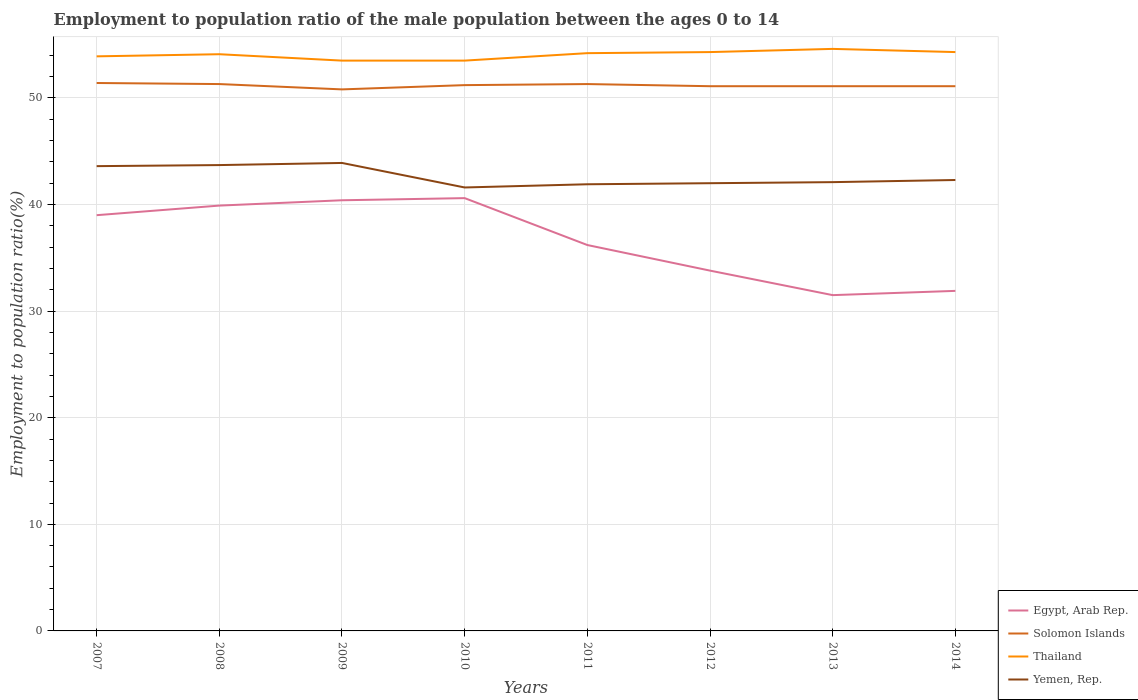Does the line corresponding to Solomon Islands intersect with the line corresponding to Yemen, Rep.?
Give a very brief answer. No. Is the number of lines equal to the number of legend labels?
Your response must be concise. Yes. Across all years, what is the maximum employment to population ratio in Thailand?
Make the answer very short. 53.5. What is the total employment to population ratio in Yemen, Rep. in the graph?
Offer a terse response. 2. What is the difference between the highest and the second highest employment to population ratio in Thailand?
Your answer should be very brief. 1.1. How many lines are there?
Offer a terse response. 4. What is the difference between two consecutive major ticks on the Y-axis?
Ensure brevity in your answer.  10. Are the values on the major ticks of Y-axis written in scientific E-notation?
Your answer should be compact. No. Does the graph contain grids?
Your answer should be compact. Yes. How many legend labels are there?
Provide a succinct answer. 4. What is the title of the graph?
Your response must be concise. Employment to population ratio of the male population between the ages 0 to 14. Does "Moldova" appear as one of the legend labels in the graph?
Offer a very short reply. No. What is the label or title of the X-axis?
Offer a very short reply. Years. What is the label or title of the Y-axis?
Your response must be concise. Employment to population ratio(%). What is the Employment to population ratio(%) in Egypt, Arab Rep. in 2007?
Offer a terse response. 39. What is the Employment to population ratio(%) in Solomon Islands in 2007?
Your response must be concise. 51.4. What is the Employment to population ratio(%) in Thailand in 2007?
Ensure brevity in your answer.  53.9. What is the Employment to population ratio(%) of Yemen, Rep. in 2007?
Keep it short and to the point. 43.6. What is the Employment to population ratio(%) of Egypt, Arab Rep. in 2008?
Offer a very short reply. 39.9. What is the Employment to population ratio(%) of Solomon Islands in 2008?
Ensure brevity in your answer.  51.3. What is the Employment to population ratio(%) in Thailand in 2008?
Keep it short and to the point. 54.1. What is the Employment to population ratio(%) of Yemen, Rep. in 2008?
Keep it short and to the point. 43.7. What is the Employment to population ratio(%) of Egypt, Arab Rep. in 2009?
Make the answer very short. 40.4. What is the Employment to population ratio(%) of Solomon Islands in 2009?
Make the answer very short. 50.8. What is the Employment to population ratio(%) in Thailand in 2009?
Your answer should be compact. 53.5. What is the Employment to population ratio(%) of Yemen, Rep. in 2009?
Offer a very short reply. 43.9. What is the Employment to population ratio(%) in Egypt, Arab Rep. in 2010?
Your answer should be compact. 40.6. What is the Employment to population ratio(%) in Solomon Islands in 2010?
Offer a terse response. 51.2. What is the Employment to population ratio(%) in Thailand in 2010?
Offer a very short reply. 53.5. What is the Employment to population ratio(%) in Yemen, Rep. in 2010?
Keep it short and to the point. 41.6. What is the Employment to population ratio(%) of Egypt, Arab Rep. in 2011?
Ensure brevity in your answer.  36.2. What is the Employment to population ratio(%) in Solomon Islands in 2011?
Offer a very short reply. 51.3. What is the Employment to population ratio(%) in Thailand in 2011?
Provide a short and direct response. 54.2. What is the Employment to population ratio(%) of Yemen, Rep. in 2011?
Offer a very short reply. 41.9. What is the Employment to population ratio(%) in Egypt, Arab Rep. in 2012?
Provide a succinct answer. 33.8. What is the Employment to population ratio(%) of Solomon Islands in 2012?
Keep it short and to the point. 51.1. What is the Employment to population ratio(%) in Thailand in 2012?
Give a very brief answer. 54.3. What is the Employment to population ratio(%) of Yemen, Rep. in 2012?
Your answer should be compact. 42. What is the Employment to population ratio(%) in Egypt, Arab Rep. in 2013?
Your answer should be very brief. 31.5. What is the Employment to population ratio(%) of Solomon Islands in 2013?
Your response must be concise. 51.1. What is the Employment to population ratio(%) of Thailand in 2013?
Offer a terse response. 54.6. What is the Employment to population ratio(%) in Yemen, Rep. in 2013?
Offer a very short reply. 42.1. What is the Employment to population ratio(%) in Egypt, Arab Rep. in 2014?
Provide a short and direct response. 31.9. What is the Employment to population ratio(%) of Solomon Islands in 2014?
Give a very brief answer. 51.1. What is the Employment to population ratio(%) of Thailand in 2014?
Your answer should be compact. 54.3. What is the Employment to population ratio(%) of Yemen, Rep. in 2014?
Provide a succinct answer. 42.3. Across all years, what is the maximum Employment to population ratio(%) of Egypt, Arab Rep.?
Ensure brevity in your answer.  40.6. Across all years, what is the maximum Employment to population ratio(%) in Solomon Islands?
Ensure brevity in your answer.  51.4. Across all years, what is the maximum Employment to population ratio(%) in Thailand?
Your response must be concise. 54.6. Across all years, what is the maximum Employment to population ratio(%) in Yemen, Rep.?
Ensure brevity in your answer.  43.9. Across all years, what is the minimum Employment to population ratio(%) in Egypt, Arab Rep.?
Offer a very short reply. 31.5. Across all years, what is the minimum Employment to population ratio(%) in Solomon Islands?
Offer a terse response. 50.8. Across all years, what is the minimum Employment to population ratio(%) of Thailand?
Keep it short and to the point. 53.5. Across all years, what is the minimum Employment to population ratio(%) of Yemen, Rep.?
Ensure brevity in your answer.  41.6. What is the total Employment to population ratio(%) of Egypt, Arab Rep. in the graph?
Offer a terse response. 293.3. What is the total Employment to population ratio(%) in Solomon Islands in the graph?
Keep it short and to the point. 409.3. What is the total Employment to population ratio(%) of Thailand in the graph?
Provide a short and direct response. 432.4. What is the total Employment to population ratio(%) of Yemen, Rep. in the graph?
Keep it short and to the point. 341.1. What is the difference between the Employment to population ratio(%) of Egypt, Arab Rep. in 2007 and that in 2008?
Your response must be concise. -0.9. What is the difference between the Employment to population ratio(%) of Yemen, Rep. in 2007 and that in 2008?
Provide a succinct answer. -0.1. What is the difference between the Employment to population ratio(%) of Egypt, Arab Rep. in 2007 and that in 2009?
Your response must be concise. -1.4. What is the difference between the Employment to population ratio(%) in Solomon Islands in 2007 and that in 2009?
Offer a terse response. 0.6. What is the difference between the Employment to population ratio(%) of Thailand in 2007 and that in 2009?
Your answer should be compact. 0.4. What is the difference between the Employment to population ratio(%) in Yemen, Rep. in 2007 and that in 2009?
Provide a short and direct response. -0.3. What is the difference between the Employment to population ratio(%) of Egypt, Arab Rep. in 2007 and that in 2010?
Your answer should be compact. -1.6. What is the difference between the Employment to population ratio(%) of Yemen, Rep. in 2007 and that in 2010?
Ensure brevity in your answer.  2. What is the difference between the Employment to population ratio(%) of Solomon Islands in 2007 and that in 2011?
Ensure brevity in your answer.  0.1. What is the difference between the Employment to population ratio(%) of Egypt, Arab Rep. in 2007 and that in 2012?
Your response must be concise. 5.2. What is the difference between the Employment to population ratio(%) in Solomon Islands in 2007 and that in 2012?
Ensure brevity in your answer.  0.3. What is the difference between the Employment to population ratio(%) of Thailand in 2007 and that in 2012?
Provide a short and direct response. -0.4. What is the difference between the Employment to population ratio(%) of Yemen, Rep. in 2007 and that in 2013?
Your response must be concise. 1.5. What is the difference between the Employment to population ratio(%) of Egypt, Arab Rep. in 2007 and that in 2014?
Provide a short and direct response. 7.1. What is the difference between the Employment to population ratio(%) of Solomon Islands in 2007 and that in 2014?
Offer a terse response. 0.3. What is the difference between the Employment to population ratio(%) in Thailand in 2007 and that in 2014?
Make the answer very short. -0.4. What is the difference between the Employment to population ratio(%) in Yemen, Rep. in 2007 and that in 2014?
Keep it short and to the point. 1.3. What is the difference between the Employment to population ratio(%) in Egypt, Arab Rep. in 2008 and that in 2009?
Your answer should be very brief. -0.5. What is the difference between the Employment to population ratio(%) in Solomon Islands in 2008 and that in 2009?
Your response must be concise. 0.5. What is the difference between the Employment to population ratio(%) in Thailand in 2008 and that in 2009?
Ensure brevity in your answer.  0.6. What is the difference between the Employment to population ratio(%) in Yemen, Rep. in 2008 and that in 2009?
Give a very brief answer. -0.2. What is the difference between the Employment to population ratio(%) of Egypt, Arab Rep. in 2008 and that in 2010?
Make the answer very short. -0.7. What is the difference between the Employment to population ratio(%) in Yemen, Rep. in 2008 and that in 2010?
Your answer should be compact. 2.1. What is the difference between the Employment to population ratio(%) in Solomon Islands in 2008 and that in 2011?
Offer a terse response. 0. What is the difference between the Employment to population ratio(%) of Yemen, Rep. in 2008 and that in 2011?
Your answer should be very brief. 1.8. What is the difference between the Employment to population ratio(%) of Egypt, Arab Rep. in 2008 and that in 2012?
Offer a terse response. 6.1. What is the difference between the Employment to population ratio(%) in Egypt, Arab Rep. in 2008 and that in 2013?
Your answer should be compact. 8.4. What is the difference between the Employment to population ratio(%) in Yemen, Rep. in 2008 and that in 2013?
Your answer should be compact. 1.6. What is the difference between the Employment to population ratio(%) of Solomon Islands in 2008 and that in 2014?
Make the answer very short. 0.2. What is the difference between the Employment to population ratio(%) of Solomon Islands in 2009 and that in 2010?
Offer a very short reply. -0.4. What is the difference between the Employment to population ratio(%) of Solomon Islands in 2009 and that in 2011?
Provide a short and direct response. -0.5. What is the difference between the Employment to population ratio(%) of Thailand in 2009 and that in 2011?
Your response must be concise. -0.7. What is the difference between the Employment to population ratio(%) in Yemen, Rep. in 2009 and that in 2011?
Your answer should be compact. 2. What is the difference between the Employment to population ratio(%) of Solomon Islands in 2009 and that in 2012?
Make the answer very short. -0.3. What is the difference between the Employment to population ratio(%) in Thailand in 2009 and that in 2012?
Your answer should be compact. -0.8. What is the difference between the Employment to population ratio(%) in Egypt, Arab Rep. in 2009 and that in 2013?
Your answer should be compact. 8.9. What is the difference between the Employment to population ratio(%) of Yemen, Rep. in 2009 and that in 2013?
Offer a very short reply. 1.8. What is the difference between the Employment to population ratio(%) in Egypt, Arab Rep. in 2009 and that in 2014?
Ensure brevity in your answer.  8.5. What is the difference between the Employment to population ratio(%) of Yemen, Rep. in 2009 and that in 2014?
Offer a terse response. 1.6. What is the difference between the Employment to population ratio(%) in Egypt, Arab Rep. in 2010 and that in 2011?
Ensure brevity in your answer.  4.4. What is the difference between the Employment to population ratio(%) in Solomon Islands in 2010 and that in 2011?
Give a very brief answer. -0.1. What is the difference between the Employment to population ratio(%) in Yemen, Rep. in 2010 and that in 2011?
Give a very brief answer. -0.3. What is the difference between the Employment to population ratio(%) in Thailand in 2010 and that in 2012?
Offer a terse response. -0.8. What is the difference between the Employment to population ratio(%) of Yemen, Rep. in 2010 and that in 2012?
Keep it short and to the point. -0.4. What is the difference between the Employment to population ratio(%) of Thailand in 2010 and that in 2013?
Your response must be concise. -1.1. What is the difference between the Employment to population ratio(%) in Solomon Islands in 2010 and that in 2014?
Give a very brief answer. 0.1. What is the difference between the Employment to population ratio(%) in Egypt, Arab Rep. in 2011 and that in 2012?
Ensure brevity in your answer.  2.4. What is the difference between the Employment to population ratio(%) in Yemen, Rep. in 2011 and that in 2012?
Make the answer very short. -0.1. What is the difference between the Employment to population ratio(%) of Yemen, Rep. in 2011 and that in 2013?
Your response must be concise. -0.2. What is the difference between the Employment to population ratio(%) in Solomon Islands in 2011 and that in 2014?
Provide a short and direct response. 0.2. What is the difference between the Employment to population ratio(%) in Yemen, Rep. in 2011 and that in 2014?
Offer a very short reply. -0.4. What is the difference between the Employment to population ratio(%) of Thailand in 2012 and that in 2013?
Your answer should be compact. -0.3. What is the difference between the Employment to population ratio(%) in Yemen, Rep. in 2012 and that in 2013?
Provide a succinct answer. -0.1. What is the difference between the Employment to population ratio(%) of Solomon Islands in 2012 and that in 2014?
Ensure brevity in your answer.  0. What is the difference between the Employment to population ratio(%) in Thailand in 2012 and that in 2014?
Provide a succinct answer. 0. What is the difference between the Employment to population ratio(%) of Yemen, Rep. in 2012 and that in 2014?
Provide a short and direct response. -0.3. What is the difference between the Employment to population ratio(%) of Solomon Islands in 2013 and that in 2014?
Make the answer very short. 0. What is the difference between the Employment to population ratio(%) of Thailand in 2013 and that in 2014?
Ensure brevity in your answer.  0.3. What is the difference between the Employment to population ratio(%) of Egypt, Arab Rep. in 2007 and the Employment to population ratio(%) of Thailand in 2008?
Your answer should be compact. -15.1. What is the difference between the Employment to population ratio(%) in Solomon Islands in 2007 and the Employment to population ratio(%) in Thailand in 2008?
Offer a terse response. -2.7. What is the difference between the Employment to population ratio(%) in Solomon Islands in 2007 and the Employment to population ratio(%) in Yemen, Rep. in 2008?
Offer a very short reply. 7.7. What is the difference between the Employment to population ratio(%) of Thailand in 2007 and the Employment to population ratio(%) of Yemen, Rep. in 2008?
Offer a terse response. 10.2. What is the difference between the Employment to population ratio(%) of Egypt, Arab Rep. in 2007 and the Employment to population ratio(%) of Yemen, Rep. in 2009?
Provide a short and direct response. -4.9. What is the difference between the Employment to population ratio(%) of Solomon Islands in 2007 and the Employment to population ratio(%) of Yemen, Rep. in 2009?
Ensure brevity in your answer.  7.5. What is the difference between the Employment to population ratio(%) in Thailand in 2007 and the Employment to population ratio(%) in Yemen, Rep. in 2009?
Your answer should be compact. 10. What is the difference between the Employment to population ratio(%) in Egypt, Arab Rep. in 2007 and the Employment to population ratio(%) in Thailand in 2010?
Give a very brief answer. -14.5. What is the difference between the Employment to population ratio(%) in Thailand in 2007 and the Employment to population ratio(%) in Yemen, Rep. in 2010?
Ensure brevity in your answer.  12.3. What is the difference between the Employment to population ratio(%) of Egypt, Arab Rep. in 2007 and the Employment to population ratio(%) of Solomon Islands in 2011?
Ensure brevity in your answer.  -12.3. What is the difference between the Employment to population ratio(%) of Egypt, Arab Rep. in 2007 and the Employment to population ratio(%) of Thailand in 2011?
Provide a succinct answer. -15.2. What is the difference between the Employment to population ratio(%) of Egypt, Arab Rep. in 2007 and the Employment to population ratio(%) of Yemen, Rep. in 2011?
Your response must be concise. -2.9. What is the difference between the Employment to population ratio(%) in Solomon Islands in 2007 and the Employment to population ratio(%) in Yemen, Rep. in 2011?
Your answer should be very brief. 9.5. What is the difference between the Employment to population ratio(%) of Egypt, Arab Rep. in 2007 and the Employment to population ratio(%) of Solomon Islands in 2012?
Your answer should be very brief. -12.1. What is the difference between the Employment to population ratio(%) in Egypt, Arab Rep. in 2007 and the Employment to population ratio(%) in Thailand in 2012?
Offer a terse response. -15.3. What is the difference between the Employment to population ratio(%) of Egypt, Arab Rep. in 2007 and the Employment to population ratio(%) of Yemen, Rep. in 2012?
Offer a very short reply. -3. What is the difference between the Employment to population ratio(%) in Solomon Islands in 2007 and the Employment to population ratio(%) in Thailand in 2012?
Your response must be concise. -2.9. What is the difference between the Employment to population ratio(%) in Egypt, Arab Rep. in 2007 and the Employment to population ratio(%) in Solomon Islands in 2013?
Your answer should be compact. -12.1. What is the difference between the Employment to population ratio(%) in Egypt, Arab Rep. in 2007 and the Employment to population ratio(%) in Thailand in 2013?
Ensure brevity in your answer.  -15.6. What is the difference between the Employment to population ratio(%) of Egypt, Arab Rep. in 2007 and the Employment to population ratio(%) of Yemen, Rep. in 2013?
Your answer should be very brief. -3.1. What is the difference between the Employment to population ratio(%) in Solomon Islands in 2007 and the Employment to population ratio(%) in Thailand in 2013?
Offer a terse response. -3.2. What is the difference between the Employment to population ratio(%) of Solomon Islands in 2007 and the Employment to population ratio(%) of Yemen, Rep. in 2013?
Offer a very short reply. 9.3. What is the difference between the Employment to population ratio(%) of Egypt, Arab Rep. in 2007 and the Employment to population ratio(%) of Solomon Islands in 2014?
Make the answer very short. -12.1. What is the difference between the Employment to population ratio(%) of Egypt, Arab Rep. in 2007 and the Employment to population ratio(%) of Thailand in 2014?
Keep it short and to the point. -15.3. What is the difference between the Employment to population ratio(%) of Thailand in 2007 and the Employment to population ratio(%) of Yemen, Rep. in 2014?
Provide a succinct answer. 11.6. What is the difference between the Employment to population ratio(%) of Egypt, Arab Rep. in 2008 and the Employment to population ratio(%) of Solomon Islands in 2009?
Offer a very short reply. -10.9. What is the difference between the Employment to population ratio(%) in Egypt, Arab Rep. in 2008 and the Employment to population ratio(%) in Thailand in 2009?
Offer a terse response. -13.6. What is the difference between the Employment to population ratio(%) of Solomon Islands in 2008 and the Employment to population ratio(%) of Thailand in 2009?
Your response must be concise. -2.2. What is the difference between the Employment to population ratio(%) in Thailand in 2008 and the Employment to population ratio(%) in Yemen, Rep. in 2009?
Keep it short and to the point. 10.2. What is the difference between the Employment to population ratio(%) of Egypt, Arab Rep. in 2008 and the Employment to population ratio(%) of Solomon Islands in 2010?
Provide a short and direct response. -11.3. What is the difference between the Employment to population ratio(%) in Egypt, Arab Rep. in 2008 and the Employment to population ratio(%) in Yemen, Rep. in 2010?
Provide a short and direct response. -1.7. What is the difference between the Employment to population ratio(%) of Solomon Islands in 2008 and the Employment to population ratio(%) of Thailand in 2010?
Keep it short and to the point. -2.2. What is the difference between the Employment to population ratio(%) of Solomon Islands in 2008 and the Employment to population ratio(%) of Yemen, Rep. in 2010?
Make the answer very short. 9.7. What is the difference between the Employment to population ratio(%) in Egypt, Arab Rep. in 2008 and the Employment to population ratio(%) in Thailand in 2011?
Give a very brief answer. -14.3. What is the difference between the Employment to population ratio(%) of Solomon Islands in 2008 and the Employment to population ratio(%) of Thailand in 2011?
Make the answer very short. -2.9. What is the difference between the Employment to population ratio(%) in Solomon Islands in 2008 and the Employment to population ratio(%) in Yemen, Rep. in 2011?
Ensure brevity in your answer.  9.4. What is the difference between the Employment to population ratio(%) in Thailand in 2008 and the Employment to population ratio(%) in Yemen, Rep. in 2011?
Give a very brief answer. 12.2. What is the difference between the Employment to population ratio(%) of Egypt, Arab Rep. in 2008 and the Employment to population ratio(%) of Solomon Islands in 2012?
Your response must be concise. -11.2. What is the difference between the Employment to population ratio(%) of Egypt, Arab Rep. in 2008 and the Employment to population ratio(%) of Thailand in 2012?
Offer a terse response. -14.4. What is the difference between the Employment to population ratio(%) in Solomon Islands in 2008 and the Employment to population ratio(%) in Thailand in 2012?
Give a very brief answer. -3. What is the difference between the Employment to population ratio(%) of Solomon Islands in 2008 and the Employment to population ratio(%) of Yemen, Rep. in 2012?
Give a very brief answer. 9.3. What is the difference between the Employment to population ratio(%) of Thailand in 2008 and the Employment to population ratio(%) of Yemen, Rep. in 2012?
Your answer should be very brief. 12.1. What is the difference between the Employment to population ratio(%) of Egypt, Arab Rep. in 2008 and the Employment to population ratio(%) of Thailand in 2013?
Give a very brief answer. -14.7. What is the difference between the Employment to population ratio(%) in Solomon Islands in 2008 and the Employment to population ratio(%) in Thailand in 2013?
Your answer should be very brief. -3.3. What is the difference between the Employment to population ratio(%) in Solomon Islands in 2008 and the Employment to population ratio(%) in Yemen, Rep. in 2013?
Give a very brief answer. 9.2. What is the difference between the Employment to population ratio(%) of Thailand in 2008 and the Employment to population ratio(%) of Yemen, Rep. in 2013?
Keep it short and to the point. 12. What is the difference between the Employment to population ratio(%) in Egypt, Arab Rep. in 2008 and the Employment to population ratio(%) in Thailand in 2014?
Offer a very short reply. -14.4. What is the difference between the Employment to population ratio(%) of Egypt, Arab Rep. in 2008 and the Employment to population ratio(%) of Yemen, Rep. in 2014?
Offer a very short reply. -2.4. What is the difference between the Employment to population ratio(%) in Solomon Islands in 2008 and the Employment to population ratio(%) in Thailand in 2014?
Offer a terse response. -3. What is the difference between the Employment to population ratio(%) in Egypt, Arab Rep. in 2009 and the Employment to population ratio(%) in Solomon Islands in 2010?
Your answer should be compact. -10.8. What is the difference between the Employment to population ratio(%) in Egypt, Arab Rep. in 2009 and the Employment to population ratio(%) in Thailand in 2010?
Provide a succinct answer. -13.1. What is the difference between the Employment to population ratio(%) of Egypt, Arab Rep. in 2009 and the Employment to population ratio(%) of Yemen, Rep. in 2010?
Your answer should be compact. -1.2. What is the difference between the Employment to population ratio(%) of Solomon Islands in 2009 and the Employment to population ratio(%) of Yemen, Rep. in 2010?
Make the answer very short. 9.2. What is the difference between the Employment to population ratio(%) of Egypt, Arab Rep. in 2009 and the Employment to population ratio(%) of Solomon Islands in 2011?
Provide a succinct answer. -10.9. What is the difference between the Employment to population ratio(%) in Egypt, Arab Rep. in 2009 and the Employment to population ratio(%) in Thailand in 2011?
Your answer should be compact. -13.8. What is the difference between the Employment to population ratio(%) of Egypt, Arab Rep. in 2009 and the Employment to population ratio(%) of Yemen, Rep. in 2011?
Your answer should be very brief. -1.5. What is the difference between the Employment to population ratio(%) in Solomon Islands in 2009 and the Employment to population ratio(%) in Yemen, Rep. in 2011?
Offer a very short reply. 8.9. What is the difference between the Employment to population ratio(%) of Thailand in 2009 and the Employment to population ratio(%) of Yemen, Rep. in 2011?
Keep it short and to the point. 11.6. What is the difference between the Employment to population ratio(%) of Egypt, Arab Rep. in 2009 and the Employment to population ratio(%) of Solomon Islands in 2012?
Make the answer very short. -10.7. What is the difference between the Employment to population ratio(%) of Egypt, Arab Rep. in 2009 and the Employment to population ratio(%) of Thailand in 2012?
Provide a short and direct response. -13.9. What is the difference between the Employment to population ratio(%) in Egypt, Arab Rep. in 2009 and the Employment to population ratio(%) in Yemen, Rep. in 2012?
Provide a succinct answer. -1.6. What is the difference between the Employment to population ratio(%) of Solomon Islands in 2009 and the Employment to population ratio(%) of Thailand in 2012?
Your answer should be very brief. -3.5. What is the difference between the Employment to population ratio(%) in Egypt, Arab Rep. in 2009 and the Employment to population ratio(%) in Solomon Islands in 2013?
Provide a short and direct response. -10.7. What is the difference between the Employment to population ratio(%) in Egypt, Arab Rep. in 2009 and the Employment to population ratio(%) in Thailand in 2013?
Give a very brief answer. -14.2. What is the difference between the Employment to population ratio(%) of Egypt, Arab Rep. in 2009 and the Employment to population ratio(%) of Yemen, Rep. in 2013?
Offer a very short reply. -1.7. What is the difference between the Employment to population ratio(%) of Solomon Islands in 2009 and the Employment to population ratio(%) of Thailand in 2013?
Offer a terse response. -3.8. What is the difference between the Employment to population ratio(%) of Solomon Islands in 2009 and the Employment to population ratio(%) of Yemen, Rep. in 2013?
Provide a succinct answer. 8.7. What is the difference between the Employment to population ratio(%) in Egypt, Arab Rep. in 2009 and the Employment to population ratio(%) in Solomon Islands in 2014?
Offer a terse response. -10.7. What is the difference between the Employment to population ratio(%) in Egypt, Arab Rep. in 2009 and the Employment to population ratio(%) in Thailand in 2014?
Your answer should be very brief. -13.9. What is the difference between the Employment to population ratio(%) in Solomon Islands in 2009 and the Employment to population ratio(%) in Thailand in 2014?
Provide a succinct answer. -3.5. What is the difference between the Employment to population ratio(%) in Solomon Islands in 2009 and the Employment to population ratio(%) in Yemen, Rep. in 2014?
Make the answer very short. 8.5. What is the difference between the Employment to population ratio(%) of Egypt, Arab Rep. in 2010 and the Employment to population ratio(%) of Thailand in 2011?
Offer a terse response. -13.6. What is the difference between the Employment to population ratio(%) of Egypt, Arab Rep. in 2010 and the Employment to population ratio(%) of Yemen, Rep. in 2011?
Provide a succinct answer. -1.3. What is the difference between the Employment to population ratio(%) in Thailand in 2010 and the Employment to population ratio(%) in Yemen, Rep. in 2011?
Your answer should be compact. 11.6. What is the difference between the Employment to population ratio(%) in Egypt, Arab Rep. in 2010 and the Employment to population ratio(%) in Thailand in 2012?
Your answer should be very brief. -13.7. What is the difference between the Employment to population ratio(%) in Egypt, Arab Rep. in 2010 and the Employment to population ratio(%) in Yemen, Rep. in 2012?
Keep it short and to the point. -1.4. What is the difference between the Employment to population ratio(%) in Solomon Islands in 2010 and the Employment to population ratio(%) in Thailand in 2013?
Offer a very short reply. -3.4. What is the difference between the Employment to population ratio(%) in Solomon Islands in 2010 and the Employment to population ratio(%) in Yemen, Rep. in 2013?
Keep it short and to the point. 9.1. What is the difference between the Employment to population ratio(%) of Thailand in 2010 and the Employment to population ratio(%) of Yemen, Rep. in 2013?
Your response must be concise. 11.4. What is the difference between the Employment to population ratio(%) in Egypt, Arab Rep. in 2010 and the Employment to population ratio(%) in Solomon Islands in 2014?
Provide a succinct answer. -10.5. What is the difference between the Employment to population ratio(%) in Egypt, Arab Rep. in 2010 and the Employment to population ratio(%) in Thailand in 2014?
Ensure brevity in your answer.  -13.7. What is the difference between the Employment to population ratio(%) of Thailand in 2010 and the Employment to population ratio(%) of Yemen, Rep. in 2014?
Offer a very short reply. 11.2. What is the difference between the Employment to population ratio(%) in Egypt, Arab Rep. in 2011 and the Employment to population ratio(%) in Solomon Islands in 2012?
Give a very brief answer. -14.9. What is the difference between the Employment to population ratio(%) in Egypt, Arab Rep. in 2011 and the Employment to population ratio(%) in Thailand in 2012?
Offer a terse response. -18.1. What is the difference between the Employment to population ratio(%) in Solomon Islands in 2011 and the Employment to population ratio(%) in Thailand in 2012?
Offer a very short reply. -3. What is the difference between the Employment to population ratio(%) in Solomon Islands in 2011 and the Employment to population ratio(%) in Yemen, Rep. in 2012?
Keep it short and to the point. 9.3. What is the difference between the Employment to population ratio(%) in Thailand in 2011 and the Employment to population ratio(%) in Yemen, Rep. in 2012?
Keep it short and to the point. 12.2. What is the difference between the Employment to population ratio(%) of Egypt, Arab Rep. in 2011 and the Employment to population ratio(%) of Solomon Islands in 2013?
Offer a very short reply. -14.9. What is the difference between the Employment to population ratio(%) in Egypt, Arab Rep. in 2011 and the Employment to population ratio(%) in Thailand in 2013?
Your response must be concise. -18.4. What is the difference between the Employment to population ratio(%) in Solomon Islands in 2011 and the Employment to population ratio(%) in Thailand in 2013?
Ensure brevity in your answer.  -3.3. What is the difference between the Employment to population ratio(%) of Solomon Islands in 2011 and the Employment to population ratio(%) of Yemen, Rep. in 2013?
Your answer should be very brief. 9.2. What is the difference between the Employment to population ratio(%) in Egypt, Arab Rep. in 2011 and the Employment to population ratio(%) in Solomon Islands in 2014?
Ensure brevity in your answer.  -14.9. What is the difference between the Employment to population ratio(%) of Egypt, Arab Rep. in 2011 and the Employment to population ratio(%) of Thailand in 2014?
Keep it short and to the point. -18.1. What is the difference between the Employment to population ratio(%) of Solomon Islands in 2011 and the Employment to population ratio(%) of Yemen, Rep. in 2014?
Give a very brief answer. 9. What is the difference between the Employment to population ratio(%) of Egypt, Arab Rep. in 2012 and the Employment to population ratio(%) of Solomon Islands in 2013?
Give a very brief answer. -17.3. What is the difference between the Employment to population ratio(%) in Egypt, Arab Rep. in 2012 and the Employment to population ratio(%) in Thailand in 2013?
Give a very brief answer. -20.8. What is the difference between the Employment to population ratio(%) of Solomon Islands in 2012 and the Employment to population ratio(%) of Thailand in 2013?
Your response must be concise. -3.5. What is the difference between the Employment to population ratio(%) in Thailand in 2012 and the Employment to population ratio(%) in Yemen, Rep. in 2013?
Your answer should be very brief. 12.2. What is the difference between the Employment to population ratio(%) in Egypt, Arab Rep. in 2012 and the Employment to population ratio(%) in Solomon Islands in 2014?
Offer a terse response. -17.3. What is the difference between the Employment to population ratio(%) in Egypt, Arab Rep. in 2012 and the Employment to population ratio(%) in Thailand in 2014?
Your answer should be very brief. -20.5. What is the difference between the Employment to population ratio(%) in Egypt, Arab Rep. in 2012 and the Employment to population ratio(%) in Yemen, Rep. in 2014?
Offer a terse response. -8.5. What is the difference between the Employment to population ratio(%) of Solomon Islands in 2012 and the Employment to population ratio(%) of Thailand in 2014?
Provide a succinct answer. -3.2. What is the difference between the Employment to population ratio(%) of Solomon Islands in 2012 and the Employment to population ratio(%) of Yemen, Rep. in 2014?
Provide a succinct answer. 8.8. What is the difference between the Employment to population ratio(%) of Thailand in 2012 and the Employment to population ratio(%) of Yemen, Rep. in 2014?
Your answer should be very brief. 12. What is the difference between the Employment to population ratio(%) in Egypt, Arab Rep. in 2013 and the Employment to population ratio(%) in Solomon Islands in 2014?
Offer a very short reply. -19.6. What is the difference between the Employment to population ratio(%) of Egypt, Arab Rep. in 2013 and the Employment to population ratio(%) of Thailand in 2014?
Your answer should be compact. -22.8. What is the difference between the Employment to population ratio(%) of Egypt, Arab Rep. in 2013 and the Employment to population ratio(%) of Yemen, Rep. in 2014?
Offer a terse response. -10.8. What is the difference between the Employment to population ratio(%) of Thailand in 2013 and the Employment to population ratio(%) of Yemen, Rep. in 2014?
Provide a succinct answer. 12.3. What is the average Employment to population ratio(%) of Egypt, Arab Rep. per year?
Make the answer very short. 36.66. What is the average Employment to population ratio(%) of Solomon Islands per year?
Make the answer very short. 51.16. What is the average Employment to population ratio(%) of Thailand per year?
Offer a very short reply. 54.05. What is the average Employment to population ratio(%) of Yemen, Rep. per year?
Your answer should be compact. 42.64. In the year 2007, what is the difference between the Employment to population ratio(%) in Egypt, Arab Rep. and Employment to population ratio(%) in Thailand?
Provide a short and direct response. -14.9. In the year 2007, what is the difference between the Employment to population ratio(%) in Solomon Islands and Employment to population ratio(%) in Thailand?
Your answer should be compact. -2.5. In the year 2008, what is the difference between the Employment to population ratio(%) in Egypt, Arab Rep. and Employment to population ratio(%) in Yemen, Rep.?
Your answer should be very brief. -3.8. In the year 2009, what is the difference between the Employment to population ratio(%) in Egypt, Arab Rep. and Employment to population ratio(%) in Solomon Islands?
Give a very brief answer. -10.4. In the year 2009, what is the difference between the Employment to population ratio(%) in Egypt, Arab Rep. and Employment to population ratio(%) in Thailand?
Offer a terse response. -13.1. In the year 2009, what is the difference between the Employment to population ratio(%) of Egypt, Arab Rep. and Employment to population ratio(%) of Yemen, Rep.?
Give a very brief answer. -3.5. In the year 2009, what is the difference between the Employment to population ratio(%) of Solomon Islands and Employment to population ratio(%) of Thailand?
Your answer should be very brief. -2.7. In the year 2009, what is the difference between the Employment to population ratio(%) of Thailand and Employment to population ratio(%) of Yemen, Rep.?
Keep it short and to the point. 9.6. In the year 2010, what is the difference between the Employment to population ratio(%) in Thailand and Employment to population ratio(%) in Yemen, Rep.?
Your response must be concise. 11.9. In the year 2011, what is the difference between the Employment to population ratio(%) of Egypt, Arab Rep. and Employment to population ratio(%) of Solomon Islands?
Provide a succinct answer. -15.1. In the year 2011, what is the difference between the Employment to population ratio(%) of Egypt, Arab Rep. and Employment to population ratio(%) of Thailand?
Ensure brevity in your answer.  -18. In the year 2011, what is the difference between the Employment to population ratio(%) of Solomon Islands and Employment to population ratio(%) of Yemen, Rep.?
Provide a short and direct response. 9.4. In the year 2012, what is the difference between the Employment to population ratio(%) of Egypt, Arab Rep. and Employment to population ratio(%) of Solomon Islands?
Give a very brief answer. -17.3. In the year 2012, what is the difference between the Employment to population ratio(%) of Egypt, Arab Rep. and Employment to population ratio(%) of Thailand?
Your answer should be very brief. -20.5. In the year 2012, what is the difference between the Employment to population ratio(%) of Solomon Islands and Employment to population ratio(%) of Thailand?
Ensure brevity in your answer.  -3.2. In the year 2012, what is the difference between the Employment to population ratio(%) in Solomon Islands and Employment to population ratio(%) in Yemen, Rep.?
Offer a terse response. 9.1. In the year 2013, what is the difference between the Employment to population ratio(%) in Egypt, Arab Rep. and Employment to population ratio(%) in Solomon Islands?
Ensure brevity in your answer.  -19.6. In the year 2013, what is the difference between the Employment to population ratio(%) of Egypt, Arab Rep. and Employment to population ratio(%) of Thailand?
Give a very brief answer. -23.1. In the year 2013, what is the difference between the Employment to population ratio(%) in Egypt, Arab Rep. and Employment to population ratio(%) in Yemen, Rep.?
Your answer should be compact. -10.6. In the year 2013, what is the difference between the Employment to population ratio(%) in Solomon Islands and Employment to population ratio(%) in Thailand?
Keep it short and to the point. -3.5. In the year 2014, what is the difference between the Employment to population ratio(%) of Egypt, Arab Rep. and Employment to population ratio(%) of Solomon Islands?
Your response must be concise. -19.2. In the year 2014, what is the difference between the Employment to population ratio(%) in Egypt, Arab Rep. and Employment to population ratio(%) in Thailand?
Give a very brief answer. -22.4. In the year 2014, what is the difference between the Employment to population ratio(%) in Solomon Islands and Employment to population ratio(%) in Thailand?
Provide a succinct answer. -3.2. In the year 2014, what is the difference between the Employment to population ratio(%) of Thailand and Employment to population ratio(%) of Yemen, Rep.?
Provide a succinct answer. 12. What is the ratio of the Employment to population ratio(%) of Egypt, Arab Rep. in 2007 to that in 2008?
Your response must be concise. 0.98. What is the ratio of the Employment to population ratio(%) in Thailand in 2007 to that in 2008?
Ensure brevity in your answer.  1. What is the ratio of the Employment to population ratio(%) of Yemen, Rep. in 2007 to that in 2008?
Your answer should be very brief. 1. What is the ratio of the Employment to population ratio(%) of Egypt, Arab Rep. in 2007 to that in 2009?
Your response must be concise. 0.97. What is the ratio of the Employment to population ratio(%) of Solomon Islands in 2007 to that in 2009?
Provide a short and direct response. 1.01. What is the ratio of the Employment to population ratio(%) of Thailand in 2007 to that in 2009?
Your response must be concise. 1.01. What is the ratio of the Employment to population ratio(%) in Yemen, Rep. in 2007 to that in 2009?
Your answer should be very brief. 0.99. What is the ratio of the Employment to population ratio(%) in Egypt, Arab Rep. in 2007 to that in 2010?
Offer a very short reply. 0.96. What is the ratio of the Employment to population ratio(%) of Thailand in 2007 to that in 2010?
Ensure brevity in your answer.  1.01. What is the ratio of the Employment to population ratio(%) of Yemen, Rep. in 2007 to that in 2010?
Your response must be concise. 1.05. What is the ratio of the Employment to population ratio(%) in Egypt, Arab Rep. in 2007 to that in 2011?
Your answer should be very brief. 1.08. What is the ratio of the Employment to population ratio(%) of Solomon Islands in 2007 to that in 2011?
Provide a succinct answer. 1. What is the ratio of the Employment to population ratio(%) of Yemen, Rep. in 2007 to that in 2011?
Your answer should be compact. 1.04. What is the ratio of the Employment to population ratio(%) of Egypt, Arab Rep. in 2007 to that in 2012?
Ensure brevity in your answer.  1.15. What is the ratio of the Employment to population ratio(%) of Solomon Islands in 2007 to that in 2012?
Provide a short and direct response. 1.01. What is the ratio of the Employment to population ratio(%) in Yemen, Rep. in 2007 to that in 2012?
Your answer should be compact. 1.04. What is the ratio of the Employment to population ratio(%) of Egypt, Arab Rep. in 2007 to that in 2013?
Offer a terse response. 1.24. What is the ratio of the Employment to population ratio(%) in Solomon Islands in 2007 to that in 2013?
Provide a succinct answer. 1.01. What is the ratio of the Employment to population ratio(%) of Thailand in 2007 to that in 2013?
Your answer should be compact. 0.99. What is the ratio of the Employment to population ratio(%) of Yemen, Rep. in 2007 to that in 2013?
Your response must be concise. 1.04. What is the ratio of the Employment to population ratio(%) of Egypt, Arab Rep. in 2007 to that in 2014?
Offer a terse response. 1.22. What is the ratio of the Employment to population ratio(%) in Solomon Islands in 2007 to that in 2014?
Make the answer very short. 1.01. What is the ratio of the Employment to population ratio(%) in Thailand in 2007 to that in 2014?
Make the answer very short. 0.99. What is the ratio of the Employment to population ratio(%) in Yemen, Rep. in 2007 to that in 2014?
Offer a terse response. 1.03. What is the ratio of the Employment to population ratio(%) of Egypt, Arab Rep. in 2008 to that in 2009?
Your answer should be very brief. 0.99. What is the ratio of the Employment to population ratio(%) of Solomon Islands in 2008 to that in 2009?
Provide a short and direct response. 1.01. What is the ratio of the Employment to population ratio(%) in Thailand in 2008 to that in 2009?
Make the answer very short. 1.01. What is the ratio of the Employment to population ratio(%) in Egypt, Arab Rep. in 2008 to that in 2010?
Offer a very short reply. 0.98. What is the ratio of the Employment to population ratio(%) in Solomon Islands in 2008 to that in 2010?
Offer a very short reply. 1. What is the ratio of the Employment to population ratio(%) in Thailand in 2008 to that in 2010?
Provide a succinct answer. 1.01. What is the ratio of the Employment to population ratio(%) of Yemen, Rep. in 2008 to that in 2010?
Provide a short and direct response. 1.05. What is the ratio of the Employment to population ratio(%) in Egypt, Arab Rep. in 2008 to that in 2011?
Offer a very short reply. 1.1. What is the ratio of the Employment to population ratio(%) in Yemen, Rep. in 2008 to that in 2011?
Provide a short and direct response. 1.04. What is the ratio of the Employment to population ratio(%) of Egypt, Arab Rep. in 2008 to that in 2012?
Make the answer very short. 1.18. What is the ratio of the Employment to population ratio(%) in Solomon Islands in 2008 to that in 2012?
Offer a terse response. 1. What is the ratio of the Employment to population ratio(%) in Thailand in 2008 to that in 2012?
Your response must be concise. 1. What is the ratio of the Employment to population ratio(%) of Yemen, Rep. in 2008 to that in 2012?
Give a very brief answer. 1.04. What is the ratio of the Employment to population ratio(%) of Egypt, Arab Rep. in 2008 to that in 2013?
Your response must be concise. 1.27. What is the ratio of the Employment to population ratio(%) in Solomon Islands in 2008 to that in 2013?
Provide a short and direct response. 1. What is the ratio of the Employment to population ratio(%) in Yemen, Rep. in 2008 to that in 2013?
Provide a succinct answer. 1.04. What is the ratio of the Employment to population ratio(%) in Egypt, Arab Rep. in 2008 to that in 2014?
Give a very brief answer. 1.25. What is the ratio of the Employment to population ratio(%) in Solomon Islands in 2008 to that in 2014?
Your answer should be very brief. 1. What is the ratio of the Employment to population ratio(%) of Yemen, Rep. in 2008 to that in 2014?
Provide a short and direct response. 1.03. What is the ratio of the Employment to population ratio(%) in Egypt, Arab Rep. in 2009 to that in 2010?
Provide a succinct answer. 1. What is the ratio of the Employment to population ratio(%) of Yemen, Rep. in 2009 to that in 2010?
Your answer should be compact. 1.06. What is the ratio of the Employment to population ratio(%) of Egypt, Arab Rep. in 2009 to that in 2011?
Make the answer very short. 1.12. What is the ratio of the Employment to population ratio(%) of Solomon Islands in 2009 to that in 2011?
Ensure brevity in your answer.  0.99. What is the ratio of the Employment to population ratio(%) of Thailand in 2009 to that in 2011?
Make the answer very short. 0.99. What is the ratio of the Employment to population ratio(%) in Yemen, Rep. in 2009 to that in 2011?
Offer a terse response. 1.05. What is the ratio of the Employment to population ratio(%) in Egypt, Arab Rep. in 2009 to that in 2012?
Provide a short and direct response. 1.2. What is the ratio of the Employment to population ratio(%) of Yemen, Rep. in 2009 to that in 2012?
Your response must be concise. 1.05. What is the ratio of the Employment to population ratio(%) of Egypt, Arab Rep. in 2009 to that in 2013?
Keep it short and to the point. 1.28. What is the ratio of the Employment to population ratio(%) in Solomon Islands in 2009 to that in 2013?
Your answer should be very brief. 0.99. What is the ratio of the Employment to population ratio(%) in Thailand in 2009 to that in 2013?
Your response must be concise. 0.98. What is the ratio of the Employment to population ratio(%) of Yemen, Rep. in 2009 to that in 2013?
Ensure brevity in your answer.  1.04. What is the ratio of the Employment to population ratio(%) in Egypt, Arab Rep. in 2009 to that in 2014?
Provide a succinct answer. 1.27. What is the ratio of the Employment to population ratio(%) in Solomon Islands in 2009 to that in 2014?
Your answer should be compact. 0.99. What is the ratio of the Employment to population ratio(%) of Yemen, Rep. in 2009 to that in 2014?
Keep it short and to the point. 1.04. What is the ratio of the Employment to population ratio(%) in Egypt, Arab Rep. in 2010 to that in 2011?
Your answer should be very brief. 1.12. What is the ratio of the Employment to population ratio(%) of Solomon Islands in 2010 to that in 2011?
Your answer should be very brief. 1. What is the ratio of the Employment to population ratio(%) in Thailand in 2010 to that in 2011?
Offer a very short reply. 0.99. What is the ratio of the Employment to population ratio(%) in Yemen, Rep. in 2010 to that in 2011?
Offer a very short reply. 0.99. What is the ratio of the Employment to population ratio(%) in Egypt, Arab Rep. in 2010 to that in 2012?
Provide a succinct answer. 1.2. What is the ratio of the Employment to population ratio(%) of Solomon Islands in 2010 to that in 2012?
Provide a succinct answer. 1. What is the ratio of the Employment to population ratio(%) in Thailand in 2010 to that in 2012?
Give a very brief answer. 0.99. What is the ratio of the Employment to population ratio(%) of Yemen, Rep. in 2010 to that in 2012?
Provide a succinct answer. 0.99. What is the ratio of the Employment to population ratio(%) in Egypt, Arab Rep. in 2010 to that in 2013?
Offer a terse response. 1.29. What is the ratio of the Employment to population ratio(%) of Solomon Islands in 2010 to that in 2013?
Ensure brevity in your answer.  1. What is the ratio of the Employment to population ratio(%) in Thailand in 2010 to that in 2013?
Make the answer very short. 0.98. What is the ratio of the Employment to population ratio(%) in Egypt, Arab Rep. in 2010 to that in 2014?
Offer a terse response. 1.27. What is the ratio of the Employment to population ratio(%) of Yemen, Rep. in 2010 to that in 2014?
Make the answer very short. 0.98. What is the ratio of the Employment to population ratio(%) in Egypt, Arab Rep. in 2011 to that in 2012?
Offer a terse response. 1.07. What is the ratio of the Employment to population ratio(%) of Yemen, Rep. in 2011 to that in 2012?
Offer a very short reply. 1. What is the ratio of the Employment to population ratio(%) in Egypt, Arab Rep. in 2011 to that in 2013?
Offer a very short reply. 1.15. What is the ratio of the Employment to population ratio(%) in Thailand in 2011 to that in 2013?
Offer a terse response. 0.99. What is the ratio of the Employment to population ratio(%) in Egypt, Arab Rep. in 2011 to that in 2014?
Offer a very short reply. 1.13. What is the ratio of the Employment to population ratio(%) of Solomon Islands in 2011 to that in 2014?
Give a very brief answer. 1. What is the ratio of the Employment to population ratio(%) of Egypt, Arab Rep. in 2012 to that in 2013?
Your answer should be compact. 1.07. What is the ratio of the Employment to population ratio(%) in Solomon Islands in 2012 to that in 2013?
Keep it short and to the point. 1. What is the ratio of the Employment to population ratio(%) in Thailand in 2012 to that in 2013?
Make the answer very short. 0.99. What is the ratio of the Employment to population ratio(%) of Yemen, Rep. in 2012 to that in 2013?
Offer a terse response. 1. What is the ratio of the Employment to population ratio(%) of Egypt, Arab Rep. in 2012 to that in 2014?
Offer a very short reply. 1.06. What is the ratio of the Employment to population ratio(%) of Egypt, Arab Rep. in 2013 to that in 2014?
Give a very brief answer. 0.99. What is the ratio of the Employment to population ratio(%) of Thailand in 2013 to that in 2014?
Make the answer very short. 1.01. What is the difference between the highest and the lowest Employment to population ratio(%) of Solomon Islands?
Offer a terse response. 0.6. What is the difference between the highest and the lowest Employment to population ratio(%) in Yemen, Rep.?
Make the answer very short. 2.3. 